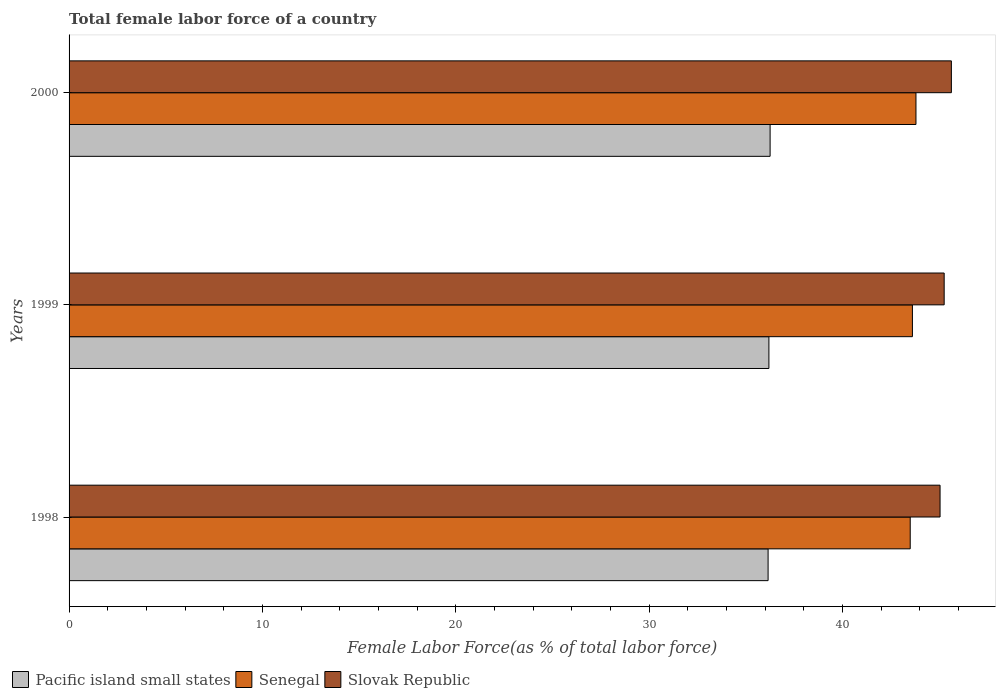How many groups of bars are there?
Give a very brief answer. 3. Are the number of bars per tick equal to the number of legend labels?
Your answer should be very brief. Yes. What is the label of the 2nd group of bars from the top?
Make the answer very short. 1999. What is the percentage of female labor force in Slovak Republic in 1998?
Your answer should be compact. 45.05. Across all years, what is the maximum percentage of female labor force in Pacific island small states?
Your answer should be compact. 36.26. Across all years, what is the minimum percentage of female labor force in Pacific island small states?
Your answer should be compact. 36.15. What is the total percentage of female labor force in Pacific island small states in the graph?
Provide a short and direct response. 108.61. What is the difference between the percentage of female labor force in Pacific island small states in 1998 and that in 2000?
Provide a short and direct response. -0.1. What is the difference between the percentage of female labor force in Pacific island small states in 2000 and the percentage of female labor force in Slovak Republic in 1998?
Your answer should be very brief. -8.79. What is the average percentage of female labor force in Pacific island small states per year?
Offer a terse response. 36.2. In the year 1998, what is the difference between the percentage of female labor force in Slovak Republic and percentage of female labor force in Pacific island small states?
Keep it short and to the point. 8.89. What is the ratio of the percentage of female labor force in Senegal in 1998 to that in 1999?
Make the answer very short. 1. Is the percentage of female labor force in Pacific island small states in 1998 less than that in 2000?
Offer a terse response. Yes. Is the difference between the percentage of female labor force in Slovak Republic in 1999 and 2000 greater than the difference between the percentage of female labor force in Pacific island small states in 1999 and 2000?
Keep it short and to the point. No. What is the difference between the highest and the second highest percentage of female labor force in Senegal?
Offer a terse response. 0.18. What is the difference between the highest and the lowest percentage of female labor force in Slovak Republic?
Your answer should be very brief. 0.59. What does the 3rd bar from the top in 1998 represents?
Your answer should be compact. Pacific island small states. What does the 3rd bar from the bottom in 2000 represents?
Provide a short and direct response. Slovak Republic. Is it the case that in every year, the sum of the percentage of female labor force in Slovak Republic and percentage of female labor force in Senegal is greater than the percentage of female labor force in Pacific island small states?
Provide a succinct answer. Yes. How many bars are there?
Keep it short and to the point. 9. Are all the bars in the graph horizontal?
Give a very brief answer. Yes. How many years are there in the graph?
Your answer should be compact. 3. What is the title of the graph?
Make the answer very short. Total female labor force of a country. What is the label or title of the X-axis?
Provide a short and direct response. Female Labor Force(as % of total labor force). What is the Female Labor Force(as % of total labor force) in Pacific island small states in 1998?
Offer a very short reply. 36.15. What is the Female Labor Force(as % of total labor force) in Senegal in 1998?
Offer a very short reply. 43.51. What is the Female Labor Force(as % of total labor force) in Slovak Republic in 1998?
Your answer should be compact. 45.05. What is the Female Labor Force(as % of total labor force) in Pacific island small states in 1999?
Offer a very short reply. 36.2. What is the Female Labor Force(as % of total labor force) of Senegal in 1999?
Your response must be concise. 43.62. What is the Female Labor Force(as % of total labor force) of Slovak Republic in 1999?
Your response must be concise. 45.26. What is the Female Labor Force(as % of total labor force) in Pacific island small states in 2000?
Keep it short and to the point. 36.26. What is the Female Labor Force(as % of total labor force) of Senegal in 2000?
Your response must be concise. 43.8. What is the Female Labor Force(as % of total labor force) of Slovak Republic in 2000?
Provide a short and direct response. 45.63. Across all years, what is the maximum Female Labor Force(as % of total labor force) in Pacific island small states?
Ensure brevity in your answer.  36.26. Across all years, what is the maximum Female Labor Force(as % of total labor force) in Senegal?
Provide a succinct answer. 43.8. Across all years, what is the maximum Female Labor Force(as % of total labor force) in Slovak Republic?
Provide a succinct answer. 45.63. Across all years, what is the minimum Female Labor Force(as % of total labor force) of Pacific island small states?
Ensure brevity in your answer.  36.15. Across all years, what is the minimum Female Labor Force(as % of total labor force) of Senegal?
Offer a very short reply. 43.51. Across all years, what is the minimum Female Labor Force(as % of total labor force) of Slovak Republic?
Keep it short and to the point. 45.05. What is the total Female Labor Force(as % of total labor force) of Pacific island small states in the graph?
Your answer should be very brief. 108.61. What is the total Female Labor Force(as % of total labor force) in Senegal in the graph?
Keep it short and to the point. 130.93. What is the total Female Labor Force(as % of total labor force) of Slovak Republic in the graph?
Give a very brief answer. 135.94. What is the difference between the Female Labor Force(as % of total labor force) in Pacific island small states in 1998 and that in 1999?
Your answer should be very brief. -0.04. What is the difference between the Female Labor Force(as % of total labor force) of Senegal in 1998 and that in 1999?
Offer a very short reply. -0.11. What is the difference between the Female Labor Force(as % of total labor force) in Slovak Republic in 1998 and that in 1999?
Your response must be concise. -0.21. What is the difference between the Female Labor Force(as % of total labor force) in Pacific island small states in 1998 and that in 2000?
Keep it short and to the point. -0.1. What is the difference between the Female Labor Force(as % of total labor force) of Senegal in 1998 and that in 2000?
Your response must be concise. -0.3. What is the difference between the Female Labor Force(as % of total labor force) of Slovak Republic in 1998 and that in 2000?
Offer a terse response. -0.59. What is the difference between the Female Labor Force(as % of total labor force) of Pacific island small states in 1999 and that in 2000?
Offer a very short reply. -0.06. What is the difference between the Female Labor Force(as % of total labor force) in Senegal in 1999 and that in 2000?
Offer a terse response. -0.18. What is the difference between the Female Labor Force(as % of total labor force) in Slovak Republic in 1999 and that in 2000?
Keep it short and to the point. -0.37. What is the difference between the Female Labor Force(as % of total labor force) of Pacific island small states in 1998 and the Female Labor Force(as % of total labor force) of Senegal in 1999?
Your answer should be very brief. -7.46. What is the difference between the Female Labor Force(as % of total labor force) of Pacific island small states in 1998 and the Female Labor Force(as % of total labor force) of Slovak Republic in 1999?
Give a very brief answer. -9.11. What is the difference between the Female Labor Force(as % of total labor force) in Senegal in 1998 and the Female Labor Force(as % of total labor force) in Slovak Republic in 1999?
Offer a very short reply. -1.76. What is the difference between the Female Labor Force(as % of total labor force) of Pacific island small states in 1998 and the Female Labor Force(as % of total labor force) of Senegal in 2000?
Provide a short and direct response. -7.65. What is the difference between the Female Labor Force(as % of total labor force) of Pacific island small states in 1998 and the Female Labor Force(as % of total labor force) of Slovak Republic in 2000?
Make the answer very short. -9.48. What is the difference between the Female Labor Force(as % of total labor force) of Senegal in 1998 and the Female Labor Force(as % of total labor force) of Slovak Republic in 2000?
Your response must be concise. -2.13. What is the difference between the Female Labor Force(as % of total labor force) in Pacific island small states in 1999 and the Female Labor Force(as % of total labor force) in Senegal in 2000?
Give a very brief answer. -7.61. What is the difference between the Female Labor Force(as % of total labor force) in Pacific island small states in 1999 and the Female Labor Force(as % of total labor force) in Slovak Republic in 2000?
Provide a succinct answer. -9.44. What is the difference between the Female Labor Force(as % of total labor force) of Senegal in 1999 and the Female Labor Force(as % of total labor force) of Slovak Republic in 2000?
Offer a very short reply. -2.02. What is the average Female Labor Force(as % of total labor force) of Pacific island small states per year?
Ensure brevity in your answer.  36.2. What is the average Female Labor Force(as % of total labor force) of Senegal per year?
Your answer should be compact. 43.64. What is the average Female Labor Force(as % of total labor force) in Slovak Republic per year?
Keep it short and to the point. 45.31. In the year 1998, what is the difference between the Female Labor Force(as % of total labor force) in Pacific island small states and Female Labor Force(as % of total labor force) in Senegal?
Provide a short and direct response. -7.35. In the year 1998, what is the difference between the Female Labor Force(as % of total labor force) of Pacific island small states and Female Labor Force(as % of total labor force) of Slovak Republic?
Ensure brevity in your answer.  -8.89. In the year 1998, what is the difference between the Female Labor Force(as % of total labor force) of Senegal and Female Labor Force(as % of total labor force) of Slovak Republic?
Ensure brevity in your answer.  -1.54. In the year 1999, what is the difference between the Female Labor Force(as % of total labor force) of Pacific island small states and Female Labor Force(as % of total labor force) of Senegal?
Your answer should be compact. -7.42. In the year 1999, what is the difference between the Female Labor Force(as % of total labor force) in Pacific island small states and Female Labor Force(as % of total labor force) in Slovak Republic?
Your response must be concise. -9.06. In the year 1999, what is the difference between the Female Labor Force(as % of total labor force) in Senegal and Female Labor Force(as % of total labor force) in Slovak Republic?
Provide a succinct answer. -1.64. In the year 2000, what is the difference between the Female Labor Force(as % of total labor force) in Pacific island small states and Female Labor Force(as % of total labor force) in Senegal?
Keep it short and to the point. -7.54. In the year 2000, what is the difference between the Female Labor Force(as % of total labor force) of Pacific island small states and Female Labor Force(as % of total labor force) of Slovak Republic?
Keep it short and to the point. -9.38. In the year 2000, what is the difference between the Female Labor Force(as % of total labor force) in Senegal and Female Labor Force(as % of total labor force) in Slovak Republic?
Offer a very short reply. -1.83. What is the ratio of the Female Labor Force(as % of total labor force) in Pacific island small states in 1998 to that in 1999?
Make the answer very short. 1. What is the ratio of the Female Labor Force(as % of total labor force) of Senegal in 1998 to that in 1999?
Provide a succinct answer. 1. What is the ratio of the Female Labor Force(as % of total labor force) in Slovak Republic in 1998 to that in 1999?
Provide a succinct answer. 1. What is the ratio of the Female Labor Force(as % of total labor force) of Senegal in 1998 to that in 2000?
Provide a short and direct response. 0.99. What is the ratio of the Female Labor Force(as % of total labor force) in Slovak Republic in 1998 to that in 2000?
Offer a very short reply. 0.99. What is the ratio of the Female Labor Force(as % of total labor force) in Slovak Republic in 1999 to that in 2000?
Make the answer very short. 0.99. What is the difference between the highest and the second highest Female Labor Force(as % of total labor force) in Pacific island small states?
Provide a short and direct response. 0.06. What is the difference between the highest and the second highest Female Labor Force(as % of total labor force) in Senegal?
Offer a terse response. 0.18. What is the difference between the highest and the second highest Female Labor Force(as % of total labor force) in Slovak Republic?
Your response must be concise. 0.37. What is the difference between the highest and the lowest Female Labor Force(as % of total labor force) of Pacific island small states?
Make the answer very short. 0.1. What is the difference between the highest and the lowest Female Labor Force(as % of total labor force) in Senegal?
Keep it short and to the point. 0.3. What is the difference between the highest and the lowest Female Labor Force(as % of total labor force) in Slovak Republic?
Provide a succinct answer. 0.59. 